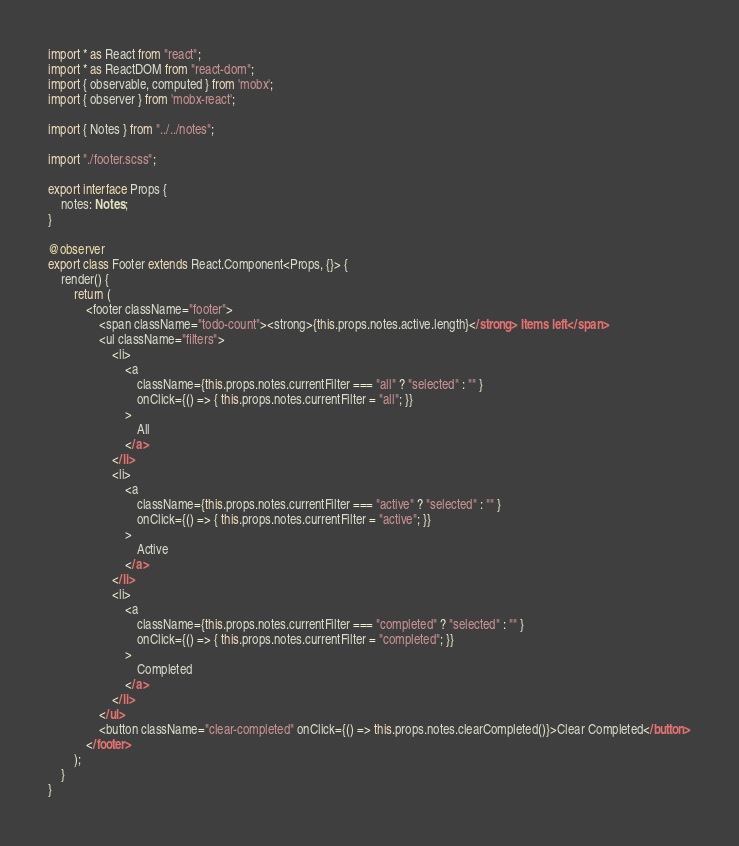Convert code to text. <code><loc_0><loc_0><loc_500><loc_500><_TypeScript_>import * as React from "react";
import * as ReactDOM from "react-dom";
import { observable, computed } from 'mobx';
import { observer } from 'mobx-react';

import { Notes } from "../../notes";

import "./footer.scss";

export interface Props {
	notes: Notes;
}

@observer
export class Footer extends React.Component<Props, {}> {
	render() {
		return (
			<footer className="footer">
				<span className="todo-count"><strong>{this.props.notes.active.length}</strong> Items left</span>
				<ul className="filters">
					<li> 
						<a
							className={this.props.notes.currentFilter === "all" ? "selected" : "" }
							onClick={() => { this.props.notes.currentFilter = "all"; }}
						>
							All
						</a>
					</li>
					<li>
						<a
							className={this.props.notes.currentFilter === "active" ? "selected" : "" }
							onClick={() => { this.props.notes.currentFilter = "active"; }}
						>
							Active
						</a>
					</li>
					<li>
						<a
							className={this.props.notes.currentFilter === "completed" ? "selected" : "" }
							onClick={() => { this.props.notes.currentFilter = "completed"; }}
						>
							Completed
						</a>
					</li>
				</ul>
				<button className="clear-completed" onClick={() => this.props.notes.clearCompleted()}>Clear Completed</button>
			</footer>
		);
	}
}</code> 